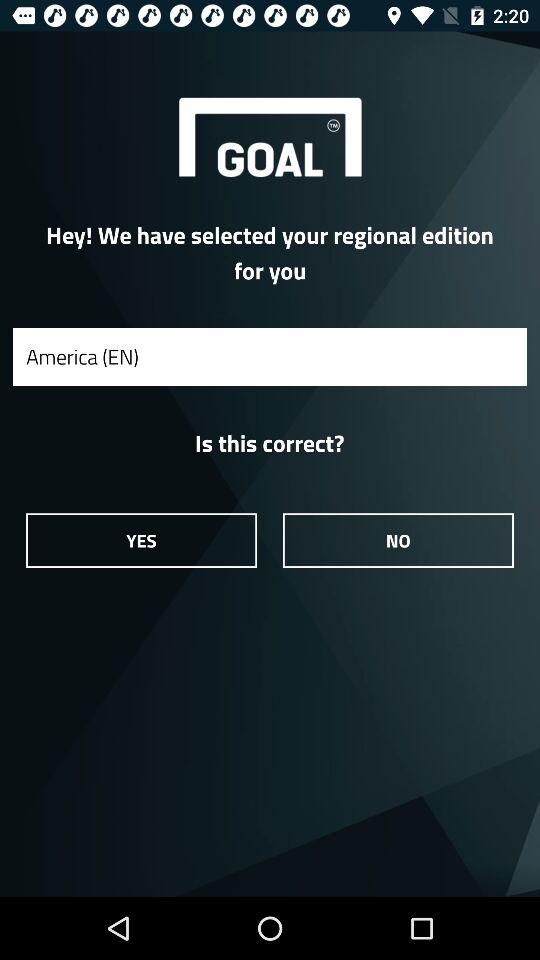How many text inputs are on the screen?
Answer the question using a single word or phrase. 1 